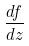<formula> <loc_0><loc_0><loc_500><loc_500>\frac { d f } { d z }</formula> 